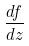<formula> <loc_0><loc_0><loc_500><loc_500>\frac { d f } { d z }</formula> 